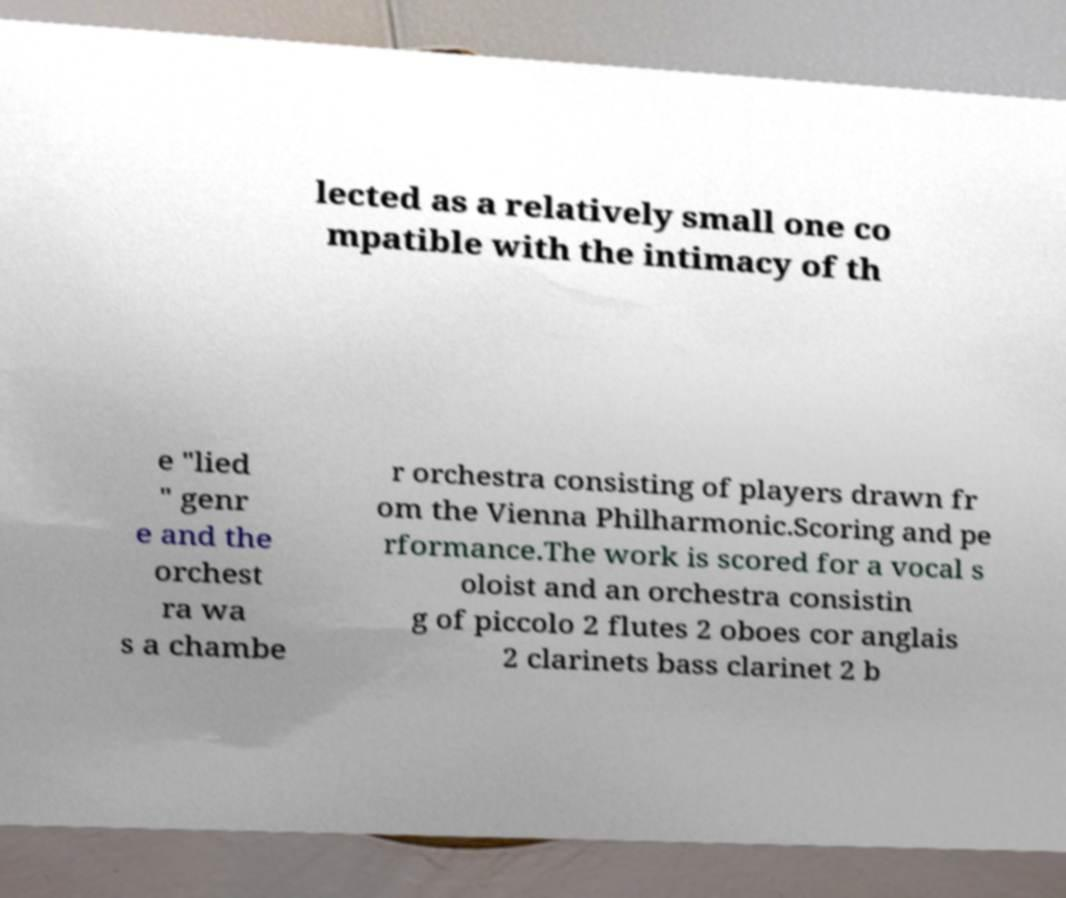For documentation purposes, I need the text within this image transcribed. Could you provide that? lected as a relatively small one co mpatible with the intimacy of th e "lied " genr e and the orchest ra wa s a chambe r orchestra consisting of players drawn fr om the Vienna Philharmonic.Scoring and pe rformance.The work is scored for a vocal s oloist and an orchestra consistin g of piccolo 2 flutes 2 oboes cor anglais 2 clarinets bass clarinet 2 b 